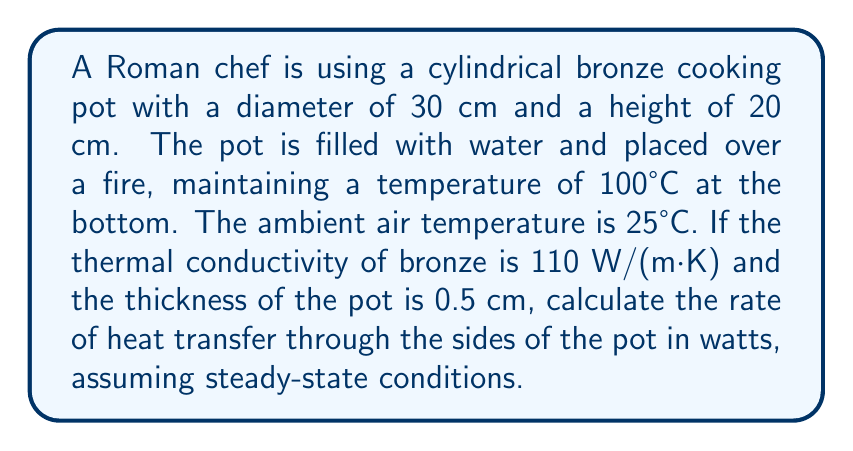Can you solve this math problem? To solve this problem, we'll use Fourier's Law of heat conduction:

$$Q = -kA\frac{dT}{dx}$$

Where:
$Q$ = rate of heat transfer (W)
$k$ = thermal conductivity of bronze (110 W/(m·K))
$A$ = surface area of the sides of the pot (m²)
$dT$ = temperature difference (°C)
$dx$ = thickness of the pot (m)

Step 1: Calculate the surface area of the sides of the pot.
$$A = \pi dh = \pi \cdot 0.30 \text{ m} \cdot 0.20 \text{ m} = 0.1885 \text{ m}^2$$

Step 2: Identify the temperature difference.
$dT = 100°C - 25°C = 75°C$

Step 3: Convert the thickness to meters.
$dx = 0.5 \text{ cm} = 0.005 \text{ m}$

Step 4: Apply Fourier's Law of heat conduction.
$$Q = -k A \frac{dT}{dx} = -110 \frac{\text{W}}{\text{m}\cdot\text{K}} \cdot 0.1885 \text{ m}^2 \cdot \frac{75 \text{ K}}{0.005 \text{ m}}$$

Step 5: Calculate the result.
$$Q = -31,102.5 \text{ W}$$

The negative sign indicates that heat flows from the higher temperature (inside the pot) to the lower temperature (outside). We're interested in the magnitude of heat transfer.
Answer: 31,102.5 W 